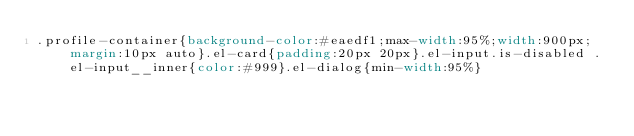Convert code to text. <code><loc_0><loc_0><loc_500><loc_500><_CSS_>.profile-container{background-color:#eaedf1;max-width:95%;width:900px;margin:10px auto}.el-card{padding:20px 20px}.el-input.is-disabled .el-input__inner{color:#999}.el-dialog{min-width:95%}</code> 